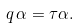Convert formula to latex. <formula><loc_0><loc_0><loc_500><loc_500>q \, \alpha = \tau \alpha .</formula> 